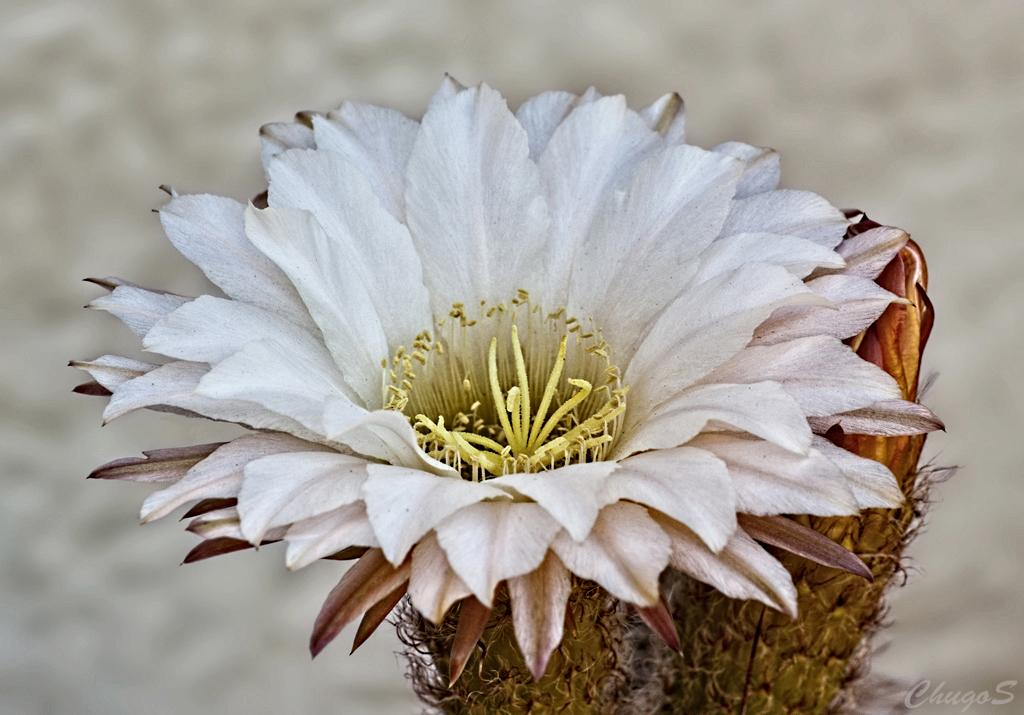What is the main subject in the foreground of the image? There is a white color flower in the foreground of the image. Is the flower part of a larger plant? Yes, the flower appears to be attached to a plant. How would you describe the background of the image? The background of the image is blurred. Where can we find the shop that sells these flowers in the image? There is no shop present in the image; it only features a white color flower and its plant. How many books are visible on the plant in the image? There are no books present in the image; it only features a white color flower and its plant. 